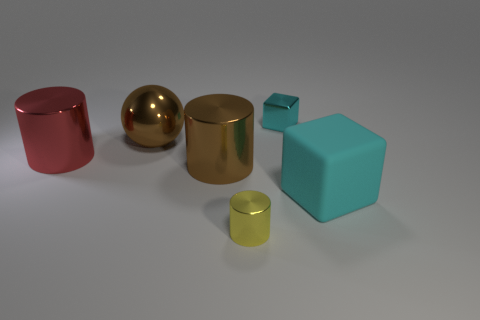Are there any other things that have the same material as the large cyan thing?
Provide a short and direct response. No. How many large brown things have the same shape as the tiny yellow shiny object?
Provide a short and direct response. 1. Is the material of the small yellow thing the same as the cyan block in front of the cyan shiny block?
Ensure brevity in your answer.  No. Are there more tiny metal things that are right of the yellow object than small green rubber objects?
Make the answer very short. Yes. The big object that is the same color as the big metal ball is what shape?
Keep it short and to the point. Cylinder. Are there any large objects that have the same material as the big red cylinder?
Ensure brevity in your answer.  Yes. Does the cyan thing that is behind the big rubber cube have the same material as the large thing to the right of the brown metal cylinder?
Ensure brevity in your answer.  No. Are there an equal number of yellow metal things that are left of the small yellow cylinder and brown things that are behind the cyan matte object?
Provide a succinct answer. No. There is a rubber object that is the same size as the metallic sphere; what is its color?
Your answer should be very brief. Cyan. Is there a small metallic cylinder of the same color as the metallic cube?
Your answer should be very brief. No. 